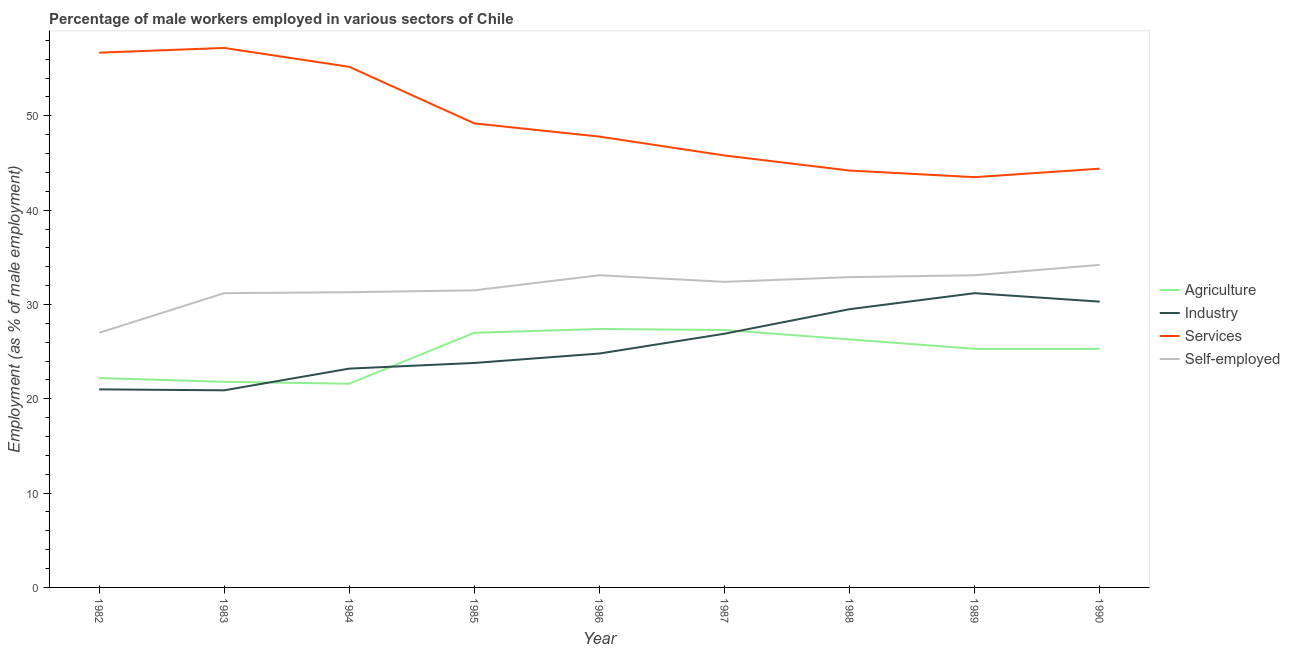Does the line corresponding to percentage of male workers in industry intersect with the line corresponding to percentage of male workers in agriculture?
Provide a short and direct response. Yes. Is the number of lines equal to the number of legend labels?
Your answer should be very brief. Yes. What is the percentage of male workers in services in 1982?
Keep it short and to the point. 56.7. Across all years, what is the maximum percentage of self employed male workers?
Your answer should be compact. 34.2. Across all years, what is the minimum percentage of male workers in services?
Give a very brief answer. 43.5. In which year was the percentage of self employed male workers maximum?
Your answer should be compact. 1990. What is the total percentage of self employed male workers in the graph?
Your answer should be very brief. 286.7. What is the difference between the percentage of male workers in agriculture in 1982 and that in 1987?
Provide a short and direct response. -5.1. What is the difference between the percentage of male workers in industry in 1982 and the percentage of male workers in services in 1987?
Give a very brief answer. -24.8. What is the average percentage of male workers in services per year?
Ensure brevity in your answer.  49.33. In the year 1985, what is the difference between the percentage of male workers in industry and percentage of male workers in services?
Ensure brevity in your answer.  -25.4. What is the ratio of the percentage of male workers in agriculture in 1989 to that in 1990?
Ensure brevity in your answer.  1. What is the difference between the highest and the second highest percentage of male workers in services?
Offer a very short reply. 0.5. What is the difference between the highest and the lowest percentage of male workers in services?
Your answer should be compact. 13.7. Is the sum of the percentage of male workers in industry in 1986 and 1988 greater than the maximum percentage of male workers in agriculture across all years?
Your answer should be compact. Yes. Is it the case that in every year, the sum of the percentage of male workers in industry and percentage of male workers in services is greater than the sum of percentage of self employed male workers and percentage of male workers in agriculture?
Make the answer very short. Yes. Does the percentage of male workers in agriculture monotonically increase over the years?
Offer a terse response. No. Is the percentage of male workers in services strictly less than the percentage of male workers in industry over the years?
Provide a succinct answer. No. How many lines are there?
Keep it short and to the point. 4. What is the difference between two consecutive major ticks on the Y-axis?
Ensure brevity in your answer.  10. Where does the legend appear in the graph?
Make the answer very short. Center right. What is the title of the graph?
Give a very brief answer. Percentage of male workers employed in various sectors of Chile. What is the label or title of the Y-axis?
Your answer should be compact. Employment (as % of male employment). What is the Employment (as % of male employment) in Agriculture in 1982?
Provide a short and direct response. 22.2. What is the Employment (as % of male employment) of Industry in 1982?
Offer a terse response. 21. What is the Employment (as % of male employment) of Services in 1982?
Keep it short and to the point. 56.7. What is the Employment (as % of male employment) of Self-employed in 1982?
Your response must be concise. 27. What is the Employment (as % of male employment) of Agriculture in 1983?
Provide a short and direct response. 21.8. What is the Employment (as % of male employment) of Industry in 1983?
Make the answer very short. 20.9. What is the Employment (as % of male employment) in Services in 1983?
Offer a terse response. 57.2. What is the Employment (as % of male employment) in Self-employed in 1983?
Provide a succinct answer. 31.2. What is the Employment (as % of male employment) in Agriculture in 1984?
Make the answer very short. 21.6. What is the Employment (as % of male employment) in Industry in 1984?
Your answer should be compact. 23.2. What is the Employment (as % of male employment) of Services in 1984?
Offer a very short reply. 55.2. What is the Employment (as % of male employment) of Self-employed in 1984?
Your answer should be compact. 31.3. What is the Employment (as % of male employment) of Industry in 1985?
Offer a terse response. 23.8. What is the Employment (as % of male employment) in Services in 1985?
Ensure brevity in your answer.  49.2. What is the Employment (as % of male employment) of Self-employed in 1985?
Make the answer very short. 31.5. What is the Employment (as % of male employment) in Agriculture in 1986?
Keep it short and to the point. 27.4. What is the Employment (as % of male employment) of Industry in 1986?
Your answer should be compact. 24.8. What is the Employment (as % of male employment) of Services in 1986?
Provide a short and direct response. 47.8. What is the Employment (as % of male employment) of Self-employed in 1986?
Give a very brief answer. 33.1. What is the Employment (as % of male employment) of Agriculture in 1987?
Provide a succinct answer. 27.3. What is the Employment (as % of male employment) in Industry in 1987?
Your answer should be very brief. 26.9. What is the Employment (as % of male employment) of Services in 1987?
Offer a terse response. 45.8. What is the Employment (as % of male employment) in Self-employed in 1987?
Make the answer very short. 32.4. What is the Employment (as % of male employment) in Agriculture in 1988?
Your answer should be compact. 26.3. What is the Employment (as % of male employment) of Industry in 1988?
Offer a very short reply. 29.5. What is the Employment (as % of male employment) in Services in 1988?
Provide a short and direct response. 44.2. What is the Employment (as % of male employment) of Self-employed in 1988?
Offer a very short reply. 32.9. What is the Employment (as % of male employment) of Agriculture in 1989?
Make the answer very short. 25.3. What is the Employment (as % of male employment) in Industry in 1989?
Offer a terse response. 31.2. What is the Employment (as % of male employment) of Services in 1989?
Provide a short and direct response. 43.5. What is the Employment (as % of male employment) of Self-employed in 1989?
Offer a very short reply. 33.1. What is the Employment (as % of male employment) in Agriculture in 1990?
Make the answer very short. 25.3. What is the Employment (as % of male employment) of Industry in 1990?
Your answer should be very brief. 30.3. What is the Employment (as % of male employment) of Services in 1990?
Provide a short and direct response. 44.4. What is the Employment (as % of male employment) in Self-employed in 1990?
Offer a very short reply. 34.2. Across all years, what is the maximum Employment (as % of male employment) of Agriculture?
Give a very brief answer. 27.4. Across all years, what is the maximum Employment (as % of male employment) in Industry?
Offer a very short reply. 31.2. Across all years, what is the maximum Employment (as % of male employment) in Services?
Offer a very short reply. 57.2. Across all years, what is the maximum Employment (as % of male employment) of Self-employed?
Your response must be concise. 34.2. Across all years, what is the minimum Employment (as % of male employment) of Agriculture?
Your answer should be compact. 21.6. Across all years, what is the minimum Employment (as % of male employment) in Industry?
Make the answer very short. 20.9. Across all years, what is the minimum Employment (as % of male employment) in Services?
Give a very brief answer. 43.5. What is the total Employment (as % of male employment) of Agriculture in the graph?
Provide a short and direct response. 224.2. What is the total Employment (as % of male employment) in Industry in the graph?
Keep it short and to the point. 231.6. What is the total Employment (as % of male employment) in Services in the graph?
Your answer should be compact. 444. What is the total Employment (as % of male employment) of Self-employed in the graph?
Make the answer very short. 286.7. What is the difference between the Employment (as % of male employment) in Agriculture in 1982 and that in 1983?
Make the answer very short. 0.4. What is the difference between the Employment (as % of male employment) of Industry in 1982 and that in 1983?
Offer a terse response. 0.1. What is the difference between the Employment (as % of male employment) of Self-employed in 1982 and that in 1983?
Your answer should be compact. -4.2. What is the difference between the Employment (as % of male employment) in Services in 1982 and that in 1984?
Give a very brief answer. 1.5. What is the difference between the Employment (as % of male employment) in Self-employed in 1982 and that in 1984?
Offer a very short reply. -4.3. What is the difference between the Employment (as % of male employment) in Agriculture in 1982 and that in 1985?
Offer a very short reply. -4.8. What is the difference between the Employment (as % of male employment) of Industry in 1982 and that in 1985?
Your answer should be compact. -2.8. What is the difference between the Employment (as % of male employment) of Self-employed in 1982 and that in 1985?
Provide a succinct answer. -4.5. What is the difference between the Employment (as % of male employment) of Agriculture in 1982 and that in 1986?
Your response must be concise. -5.2. What is the difference between the Employment (as % of male employment) of Agriculture in 1982 and that in 1987?
Ensure brevity in your answer.  -5.1. What is the difference between the Employment (as % of male employment) in Services in 1982 and that in 1987?
Give a very brief answer. 10.9. What is the difference between the Employment (as % of male employment) of Self-employed in 1982 and that in 1987?
Provide a short and direct response. -5.4. What is the difference between the Employment (as % of male employment) in Agriculture in 1982 and that in 1988?
Provide a short and direct response. -4.1. What is the difference between the Employment (as % of male employment) of Industry in 1982 and that in 1988?
Offer a very short reply. -8.5. What is the difference between the Employment (as % of male employment) in Services in 1982 and that in 1988?
Provide a succinct answer. 12.5. What is the difference between the Employment (as % of male employment) of Self-employed in 1982 and that in 1988?
Offer a terse response. -5.9. What is the difference between the Employment (as % of male employment) in Agriculture in 1982 and that in 1989?
Make the answer very short. -3.1. What is the difference between the Employment (as % of male employment) of Industry in 1982 and that in 1989?
Give a very brief answer. -10.2. What is the difference between the Employment (as % of male employment) of Services in 1982 and that in 1989?
Your answer should be very brief. 13.2. What is the difference between the Employment (as % of male employment) of Self-employed in 1982 and that in 1989?
Make the answer very short. -6.1. What is the difference between the Employment (as % of male employment) of Agriculture in 1982 and that in 1990?
Give a very brief answer. -3.1. What is the difference between the Employment (as % of male employment) in Agriculture in 1983 and that in 1984?
Keep it short and to the point. 0.2. What is the difference between the Employment (as % of male employment) of Self-employed in 1983 and that in 1984?
Provide a succinct answer. -0.1. What is the difference between the Employment (as % of male employment) of Industry in 1983 and that in 1985?
Give a very brief answer. -2.9. What is the difference between the Employment (as % of male employment) of Agriculture in 1983 and that in 1986?
Keep it short and to the point. -5.6. What is the difference between the Employment (as % of male employment) of Services in 1983 and that in 1986?
Offer a terse response. 9.4. What is the difference between the Employment (as % of male employment) of Self-employed in 1983 and that in 1986?
Your answer should be very brief. -1.9. What is the difference between the Employment (as % of male employment) in Agriculture in 1983 and that in 1987?
Give a very brief answer. -5.5. What is the difference between the Employment (as % of male employment) of Industry in 1983 and that in 1988?
Your answer should be compact. -8.6. What is the difference between the Employment (as % of male employment) of Services in 1983 and that in 1988?
Provide a succinct answer. 13. What is the difference between the Employment (as % of male employment) of Agriculture in 1983 and that in 1989?
Your answer should be compact. -3.5. What is the difference between the Employment (as % of male employment) of Industry in 1983 and that in 1989?
Provide a short and direct response. -10.3. What is the difference between the Employment (as % of male employment) of Agriculture in 1983 and that in 1990?
Offer a very short reply. -3.5. What is the difference between the Employment (as % of male employment) of Industry in 1983 and that in 1990?
Your response must be concise. -9.4. What is the difference between the Employment (as % of male employment) of Self-employed in 1983 and that in 1990?
Ensure brevity in your answer.  -3. What is the difference between the Employment (as % of male employment) in Industry in 1984 and that in 1985?
Provide a succinct answer. -0.6. What is the difference between the Employment (as % of male employment) of Self-employed in 1984 and that in 1985?
Your answer should be compact. -0.2. What is the difference between the Employment (as % of male employment) of Services in 1984 and that in 1986?
Keep it short and to the point. 7.4. What is the difference between the Employment (as % of male employment) in Services in 1984 and that in 1987?
Your answer should be very brief. 9.4. What is the difference between the Employment (as % of male employment) of Self-employed in 1984 and that in 1987?
Offer a terse response. -1.1. What is the difference between the Employment (as % of male employment) of Agriculture in 1984 and that in 1988?
Ensure brevity in your answer.  -4.7. What is the difference between the Employment (as % of male employment) in Industry in 1984 and that in 1988?
Your answer should be very brief. -6.3. What is the difference between the Employment (as % of male employment) of Self-employed in 1984 and that in 1988?
Your answer should be very brief. -1.6. What is the difference between the Employment (as % of male employment) in Agriculture in 1984 and that in 1989?
Keep it short and to the point. -3.7. What is the difference between the Employment (as % of male employment) in Industry in 1984 and that in 1989?
Offer a very short reply. -8. What is the difference between the Employment (as % of male employment) of Services in 1984 and that in 1989?
Give a very brief answer. 11.7. What is the difference between the Employment (as % of male employment) in Agriculture in 1984 and that in 1990?
Your answer should be very brief. -3.7. What is the difference between the Employment (as % of male employment) of Industry in 1984 and that in 1990?
Your answer should be compact. -7.1. What is the difference between the Employment (as % of male employment) of Services in 1984 and that in 1990?
Make the answer very short. 10.8. What is the difference between the Employment (as % of male employment) in Agriculture in 1985 and that in 1986?
Ensure brevity in your answer.  -0.4. What is the difference between the Employment (as % of male employment) in Industry in 1985 and that in 1986?
Your response must be concise. -1. What is the difference between the Employment (as % of male employment) of Services in 1985 and that in 1986?
Make the answer very short. 1.4. What is the difference between the Employment (as % of male employment) in Agriculture in 1985 and that in 1987?
Keep it short and to the point. -0.3. What is the difference between the Employment (as % of male employment) of Industry in 1985 and that in 1987?
Provide a short and direct response. -3.1. What is the difference between the Employment (as % of male employment) in Services in 1985 and that in 1987?
Your answer should be compact. 3.4. What is the difference between the Employment (as % of male employment) of Self-employed in 1985 and that in 1987?
Give a very brief answer. -0.9. What is the difference between the Employment (as % of male employment) in Industry in 1985 and that in 1988?
Ensure brevity in your answer.  -5.7. What is the difference between the Employment (as % of male employment) in Services in 1985 and that in 1988?
Keep it short and to the point. 5. What is the difference between the Employment (as % of male employment) of Industry in 1985 and that in 1989?
Give a very brief answer. -7.4. What is the difference between the Employment (as % of male employment) of Agriculture in 1985 and that in 1990?
Your response must be concise. 1.7. What is the difference between the Employment (as % of male employment) of Industry in 1985 and that in 1990?
Give a very brief answer. -6.5. What is the difference between the Employment (as % of male employment) in Services in 1985 and that in 1990?
Give a very brief answer. 4.8. What is the difference between the Employment (as % of male employment) of Agriculture in 1986 and that in 1987?
Provide a succinct answer. 0.1. What is the difference between the Employment (as % of male employment) in Industry in 1986 and that in 1987?
Provide a succinct answer. -2.1. What is the difference between the Employment (as % of male employment) of Services in 1986 and that in 1987?
Give a very brief answer. 2. What is the difference between the Employment (as % of male employment) in Self-employed in 1986 and that in 1987?
Offer a very short reply. 0.7. What is the difference between the Employment (as % of male employment) in Agriculture in 1986 and that in 1988?
Your answer should be very brief. 1.1. What is the difference between the Employment (as % of male employment) in Industry in 1986 and that in 1988?
Keep it short and to the point. -4.7. What is the difference between the Employment (as % of male employment) in Services in 1986 and that in 1988?
Provide a short and direct response. 3.6. What is the difference between the Employment (as % of male employment) in Industry in 1986 and that in 1989?
Provide a succinct answer. -6.4. What is the difference between the Employment (as % of male employment) in Services in 1986 and that in 1989?
Offer a very short reply. 4.3. What is the difference between the Employment (as % of male employment) in Industry in 1986 and that in 1990?
Your answer should be very brief. -5.5. What is the difference between the Employment (as % of male employment) in Self-employed in 1986 and that in 1990?
Offer a very short reply. -1.1. What is the difference between the Employment (as % of male employment) of Agriculture in 1987 and that in 1988?
Keep it short and to the point. 1. What is the difference between the Employment (as % of male employment) in Agriculture in 1987 and that in 1989?
Provide a short and direct response. 2. What is the difference between the Employment (as % of male employment) in Services in 1987 and that in 1989?
Offer a very short reply. 2.3. What is the difference between the Employment (as % of male employment) in Self-employed in 1987 and that in 1989?
Your response must be concise. -0.7. What is the difference between the Employment (as % of male employment) of Industry in 1987 and that in 1990?
Offer a very short reply. -3.4. What is the difference between the Employment (as % of male employment) of Services in 1987 and that in 1990?
Your answer should be compact. 1.4. What is the difference between the Employment (as % of male employment) in Services in 1988 and that in 1989?
Make the answer very short. 0.7. What is the difference between the Employment (as % of male employment) in Self-employed in 1988 and that in 1989?
Offer a terse response. -0.2. What is the difference between the Employment (as % of male employment) of Agriculture in 1988 and that in 1990?
Provide a succinct answer. 1. What is the difference between the Employment (as % of male employment) in Industry in 1989 and that in 1990?
Offer a terse response. 0.9. What is the difference between the Employment (as % of male employment) of Services in 1989 and that in 1990?
Ensure brevity in your answer.  -0.9. What is the difference between the Employment (as % of male employment) in Self-employed in 1989 and that in 1990?
Provide a succinct answer. -1.1. What is the difference between the Employment (as % of male employment) in Agriculture in 1982 and the Employment (as % of male employment) in Industry in 1983?
Your response must be concise. 1.3. What is the difference between the Employment (as % of male employment) in Agriculture in 1982 and the Employment (as % of male employment) in Services in 1983?
Provide a short and direct response. -35. What is the difference between the Employment (as % of male employment) in Industry in 1982 and the Employment (as % of male employment) in Services in 1983?
Provide a short and direct response. -36.2. What is the difference between the Employment (as % of male employment) of Services in 1982 and the Employment (as % of male employment) of Self-employed in 1983?
Offer a very short reply. 25.5. What is the difference between the Employment (as % of male employment) in Agriculture in 1982 and the Employment (as % of male employment) in Industry in 1984?
Give a very brief answer. -1. What is the difference between the Employment (as % of male employment) of Agriculture in 1982 and the Employment (as % of male employment) of Services in 1984?
Give a very brief answer. -33. What is the difference between the Employment (as % of male employment) of Industry in 1982 and the Employment (as % of male employment) of Services in 1984?
Ensure brevity in your answer.  -34.2. What is the difference between the Employment (as % of male employment) in Industry in 1982 and the Employment (as % of male employment) in Self-employed in 1984?
Your response must be concise. -10.3. What is the difference between the Employment (as % of male employment) of Services in 1982 and the Employment (as % of male employment) of Self-employed in 1984?
Keep it short and to the point. 25.4. What is the difference between the Employment (as % of male employment) in Agriculture in 1982 and the Employment (as % of male employment) in Services in 1985?
Offer a terse response. -27. What is the difference between the Employment (as % of male employment) of Agriculture in 1982 and the Employment (as % of male employment) of Self-employed in 1985?
Your answer should be very brief. -9.3. What is the difference between the Employment (as % of male employment) in Industry in 1982 and the Employment (as % of male employment) in Services in 1985?
Make the answer very short. -28.2. What is the difference between the Employment (as % of male employment) in Industry in 1982 and the Employment (as % of male employment) in Self-employed in 1985?
Your response must be concise. -10.5. What is the difference between the Employment (as % of male employment) of Services in 1982 and the Employment (as % of male employment) of Self-employed in 1985?
Ensure brevity in your answer.  25.2. What is the difference between the Employment (as % of male employment) of Agriculture in 1982 and the Employment (as % of male employment) of Industry in 1986?
Offer a terse response. -2.6. What is the difference between the Employment (as % of male employment) of Agriculture in 1982 and the Employment (as % of male employment) of Services in 1986?
Offer a terse response. -25.6. What is the difference between the Employment (as % of male employment) of Agriculture in 1982 and the Employment (as % of male employment) of Self-employed in 1986?
Keep it short and to the point. -10.9. What is the difference between the Employment (as % of male employment) in Industry in 1982 and the Employment (as % of male employment) in Services in 1986?
Keep it short and to the point. -26.8. What is the difference between the Employment (as % of male employment) in Industry in 1982 and the Employment (as % of male employment) in Self-employed in 1986?
Ensure brevity in your answer.  -12.1. What is the difference between the Employment (as % of male employment) in Services in 1982 and the Employment (as % of male employment) in Self-employed in 1986?
Offer a very short reply. 23.6. What is the difference between the Employment (as % of male employment) in Agriculture in 1982 and the Employment (as % of male employment) in Services in 1987?
Your answer should be compact. -23.6. What is the difference between the Employment (as % of male employment) in Agriculture in 1982 and the Employment (as % of male employment) in Self-employed in 1987?
Offer a very short reply. -10.2. What is the difference between the Employment (as % of male employment) in Industry in 1982 and the Employment (as % of male employment) in Services in 1987?
Your response must be concise. -24.8. What is the difference between the Employment (as % of male employment) in Industry in 1982 and the Employment (as % of male employment) in Self-employed in 1987?
Offer a very short reply. -11.4. What is the difference between the Employment (as % of male employment) in Services in 1982 and the Employment (as % of male employment) in Self-employed in 1987?
Offer a terse response. 24.3. What is the difference between the Employment (as % of male employment) of Agriculture in 1982 and the Employment (as % of male employment) of Industry in 1988?
Provide a short and direct response. -7.3. What is the difference between the Employment (as % of male employment) of Industry in 1982 and the Employment (as % of male employment) of Services in 1988?
Offer a very short reply. -23.2. What is the difference between the Employment (as % of male employment) in Services in 1982 and the Employment (as % of male employment) in Self-employed in 1988?
Your response must be concise. 23.8. What is the difference between the Employment (as % of male employment) in Agriculture in 1982 and the Employment (as % of male employment) in Services in 1989?
Your answer should be compact. -21.3. What is the difference between the Employment (as % of male employment) in Industry in 1982 and the Employment (as % of male employment) in Services in 1989?
Give a very brief answer. -22.5. What is the difference between the Employment (as % of male employment) of Services in 1982 and the Employment (as % of male employment) of Self-employed in 1989?
Your answer should be compact. 23.6. What is the difference between the Employment (as % of male employment) in Agriculture in 1982 and the Employment (as % of male employment) in Industry in 1990?
Your answer should be very brief. -8.1. What is the difference between the Employment (as % of male employment) in Agriculture in 1982 and the Employment (as % of male employment) in Services in 1990?
Provide a succinct answer. -22.2. What is the difference between the Employment (as % of male employment) in Industry in 1982 and the Employment (as % of male employment) in Services in 1990?
Offer a terse response. -23.4. What is the difference between the Employment (as % of male employment) in Services in 1982 and the Employment (as % of male employment) in Self-employed in 1990?
Your answer should be compact. 22.5. What is the difference between the Employment (as % of male employment) of Agriculture in 1983 and the Employment (as % of male employment) of Services in 1984?
Your answer should be compact. -33.4. What is the difference between the Employment (as % of male employment) in Industry in 1983 and the Employment (as % of male employment) in Services in 1984?
Your response must be concise. -34.3. What is the difference between the Employment (as % of male employment) of Industry in 1983 and the Employment (as % of male employment) of Self-employed in 1984?
Make the answer very short. -10.4. What is the difference between the Employment (as % of male employment) of Services in 1983 and the Employment (as % of male employment) of Self-employed in 1984?
Your answer should be compact. 25.9. What is the difference between the Employment (as % of male employment) of Agriculture in 1983 and the Employment (as % of male employment) of Industry in 1985?
Offer a very short reply. -2. What is the difference between the Employment (as % of male employment) of Agriculture in 1983 and the Employment (as % of male employment) of Services in 1985?
Offer a terse response. -27.4. What is the difference between the Employment (as % of male employment) of Industry in 1983 and the Employment (as % of male employment) of Services in 1985?
Keep it short and to the point. -28.3. What is the difference between the Employment (as % of male employment) in Industry in 1983 and the Employment (as % of male employment) in Self-employed in 1985?
Ensure brevity in your answer.  -10.6. What is the difference between the Employment (as % of male employment) of Services in 1983 and the Employment (as % of male employment) of Self-employed in 1985?
Ensure brevity in your answer.  25.7. What is the difference between the Employment (as % of male employment) in Agriculture in 1983 and the Employment (as % of male employment) in Self-employed in 1986?
Your answer should be very brief. -11.3. What is the difference between the Employment (as % of male employment) of Industry in 1983 and the Employment (as % of male employment) of Services in 1986?
Provide a short and direct response. -26.9. What is the difference between the Employment (as % of male employment) in Services in 1983 and the Employment (as % of male employment) in Self-employed in 1986?
Make the answer very short. 24.1. What is the difference between the Employment (as % of male employment) of Agriculture in 1983 and the Employment (as % of male employment) of Industry in 1987?
Keep it short and to the point. -5.1. What is the difference between the Employment (as % of male employment) in Agriculture in 1983 and the Employment (as % of male employment) in Self-employed in 1987?
Your response must be concise. -10.6. What is the difference between the Employment (as % of male employment) of Industry in 1983 and the Employment (as % of male employment) of Services in 1987?
Your response must be concise. -24.9. What is the difference between the Employment (as % of male employment) in Industry in 1983 and the Employment (as % of male employment) in Self-employed in 1987?
Offer a terse response. -11.5. What is the difference between the Employment (as % of male employment) of Services in 1983 and the Employment (as % of male employment) of Self-employed in 1987?
Your response must be concise. 24.8. What is the difference between the Employment (as % of male employment) of Agriculture in 1983 and the Employment (as % of male employment) of Services in 1988?
Offer a very short reply. -22.4. What is the difference between the Employment (as % of male employment) in Industry in 1983 and the Employment (as % of male employment) in Services in 1988?
Make the answer very short. -23.3. What is the difference between the Employment (as % of male employment) of Services in 1983 and the Employment (as % of male employment) of Self-employed in 1988?
Offer a very short reply. 24.3. What is the difference between the Employment (as % of male employment) in Agriculture in 1983 and the Employment (as % of male employment) in Industry in 1989?
Your answer should be compact. -9.4. What is the difference between the Employment (as % of male employment) of Agriculture in 1983 and the Employment (as % of male employment) of Services in 1989?
Your answer should be compact. -21.7. What is the difference between the Employment (as % of male employment) of Agriculture in 1983 and the Employment (as % of male employment) of Self-employed in 1989?
Provide a succinct answer. -11.3. What is the difference between the Employment (as % of male employment) of Industry in 1983 and the Employment (as % of male employment) of Services in 1989?
Your response must be concise. -22.6. What is the difference between the Employment (as % of male employment) in Industry in 1983 and the Employment (as % of male employment) in Self-employed in 1989?
Your answer should be compact. -12.2. What is the difference between the Employment (as % of male employment) in Services in 1983 and the Employment (as % of male employment) in Self-employed in 1989?
Ensure brevity in your answer.  24.1. What is the difference between the Employment (as % of male employment) of Agriculture in 1983 and the Employment (as % of male employment) of Services in 1990?
Your answer should be compact. -22.6. What is the difference between the Employment (as % of male employment) in Industry in 1983 and the Employment (as % of male employment) in Services in 1990?
Provide a succinct answer. -23.5. What is the difference between the Employment (as % of male employment) of Services in 1983 and the Employment (as % of male employment) of Self-employed in 1990?
Offer a very short reply. 23. What is the difference between the Employment (as % of male employment) in Agriculture in 1984 and the Employment (as % of male employment) in Services in 1985?
Your answer should be compact. -27.6. What is the difference between the Employment (as % of male employment) of Services in 1984 and the Employment (as % of male employment) of Self-employed in 1985?
Your answer should be compact. 23.7. What is the difference between the Employment (as % of male employment) of Agriculture in 1984 and the Employment (as % of male employment) of Services in 1986?
Your answer should be very brief. -26.2. What is the difference between the Employment (as % of male employment) in Agriculture in 1984 and the Employment (as % of male employment) in Self-employed in 1986?
Provide a short and direct response. -11.5. What is the difference between the Employment (as % of male employment) of Industry in 1984 and the Employment (as % of male employment) of Services in 1986?
Your answer should be compact. -24.6. What is the difference between the Employment (as % of male employment) of Industry in 1984 and the Employment (as % of male employment) of Self-employed in 1986?
Give a very brief answer. -9.9. What is the difference between the Employment (as % of male employment) of Services in 1984 and the Employment (as % of male employment) of Self-employed in 1986?
Ensure brevity in your answer.  22.1. What is the difference between the Employment (as % of male employment) of Agriculture in 1984 and the Employment (as % of male employment) of Services in 1987?
Offer a terse response. -24.2. What is the difference between the Employment (as % of male employment) in Agriculture in 1984 and the Employment (as % of male employment) in Self-employed in 1987?
Give a very brief answer. -10.8. What is the difference between the Employment (as % of male employment) in Industry in 1984 and the Employment (as % of male employment) in Services in 1987?
Ensure brevity in your answer.  -22.6. What is the difference between the Employment (as % of male employment) of Services in 1984 and the Employment (as % of male employment) of Self-employed in 1987?
Provide a succinct answer. 22.8. What is the difference between the Employment (as % of male employment) of Agriculture in 1984 and the Employment (as % of male employment) of Industry in 1988?
Offer a terse response. -7.9. What is the difference between the Employment (as % of male employment) of Agriculture in 1984 and the Employment (as % of male employment) of Services in 1988?
Offer a very short reply. -22.6. What is the difference between the Employment (as % of male employment) in Industry in 1984 and the Employment (as % of male employment) in Services in 1988?
Offer a terse response. -21. What is the difference between the Employment (as % of male employment) of Industry in 1984 and the Employment (as % of male employment) of Self-employed in 1988?
Your answer should be compact. -9.7. What is the difference between the Employment (as % of male employment) of Services in 1984 and the Employment (as % of male employment) of Self-employed in 1988?
Offer a very short reply. 22.3. What is the difference between the Employment (as % of male employment) of Agriculture in 1984 and the Employment (as % of male employment) of Services in 1989?
Offer a very short reply. -21.9. What is the difference between the Employment (as % of male employment) of Agriculture in 1984 and the Employment (as % of male employment) of Self-employed in 1989?
Your answer should be compact. -11.5. What is the difference between the Employment (as % of male employment) of Industry in 1984 and the Employment (as % of male employment) of Services in 1989?
Give a very brief answer. -20.3. What is the difference between the Employment (as % of male employment) of Industry in 1984 and the Employment (as % of male employment) of Self-employed in 1989?
Your response must be concise. -9.9. What is the difference between the Employment (as % of male employment) in Services in 1984 and the Employment (as % of male employment) in Self-employed in 1989?
Offer a terse response. 22.1. What is the difference between the Employment (as % of male employment) in Agriculture in 1984 and the Employment (as % of male employment) in Industry in 1990?
Give a very brief answer. -8.7. What is the difference between the Employment (as % of male employment) of Agriculture in 1984 and the Employment (as % of male employment) of Services in 1990?
Provide a short and direct response. -22.8. What is the difference between the Employment (as % of male employment) of Agriculture in 1984 and the Employment (as % of male employment) of Self-employed in 1990?
Offer a very short reply. -12.6. What is the difference between the Employment (as % of male employment) in Industry in 1984 and the Employment (as % of male employment) in Services in 1990?
Offer a very short reply. -21.2. What is the difference between the Employment (as % of male employment) in Industry in 1984 and the Employment (as % of male employment) in Self-employed in 1990?
Offer a very short reply. -11. What is the difference between the Employment (as % of male employment) of Agriculture in 1985 and the Employment (as % of male employment) of Services in 1986?
Offer a very short reply. -20.8. What is the difference between the Employment (as % of male employment) of Agriculture in 1985 and the Employment (as % of male employment) of Self-employed in 1986?
Offer a terse response. -6.1. What is the difference between the Employment (as % of male employment) in Services in 1985 and the Employment (as % of male employment) in Self-employed in 1986?
Keep it short and to the point. 16.1. What is the difference between the Employment (as % of male employment) in Agriculture in 1985 and the Employment (as % of male employment) in Services in 1987?
Your answer should be compact. -18.8. What is the difference between the Employment (as % of male employment) in Agriculture in 1985 and the Employment (as % of male employment) in Self-employed in 1987?
Provide a succinct answer. -5.4. What is the difference between the Employment (as % of male employment) in Industry in 1985 and the Employment (as % of male employment) in Services in 1987?
Give a very brief answer. -22. What is the difference between the Employment (as % of male employment) in Industry in 1985 and the Employment (as % of male employment) in Self-employed in 1987?
Give a very brief answer. -8.6. What is the difference between the Employment (as % of male employment) of Agriculture in 1985 and the Employment (as % of male employment) of Services in 1988?
Offer a very short reply. -17.2. What is the difference between the Employment (as % of male employment) in Agriculture in 1985 and the Employment (as % of male employment) in Self-employed in 1988?
Give a very brief answer. -5.9. What is the difference between the Employment (as % of male employment) of Industry in 1985 and the Employment (as % of male employment) of Services in 1988?
Keep it short and to the point. -20.4. What is the difference between the Employment (as % of male employment) of Industry in 1985 and the Employment (as % of male employment) of Self-employed in 1988?
Give a very brief answer. -9.1. What is the difference between the Employment (as % of male employment) in Agriculture in 1985 and the Employment (as % of male employment) in Services in 1989?
Offer a terse response. -16.5. What is the difference between the Employment (as % of male employment) in Agriculture in 1985 and the Employment (as % of male employment) in Self-employed in 1989?
Your answer should be compact. -6.1. What is the difference between the Employment (as % of male employment) in Industry in 1985 and the Employment (as % of male employment) in Services in 1989?
Your answer should be compact. -19.7. What is the difference between the Employment (as % of male employment) of Services in 1985 and the Employment (as % of male employment) of Self-employed in 1989?
Ensure brevity in your answer.  16.1. What is the difference between the Employment (as % of male employment) in Agriculture in 1985 and the Employment (as % of male employment) in Services in 1990?
Offer a terse response. -17.4. What is the difference between the Employment (as % of male employment) of Industry in 1985 and the Employment (as % of male employment) of Services in 1990?
Make the answer very short. -20.6. What is the difference between the Employment (as % of male employment) of Industry in 1985 and the Employment (as % of male employment) of Self-employed in 1990?
Make the answer very short. -10.4. What is the difference between the Employment (as % of male employment) of Agriculture in 1986 and the Employment (as % of male employment) of Industry in 1987?
Give a very brief answer. 0.5. What is the difference between the Employment (as % of male employment) of Agriculture in 1986 and the Employment (as % of male employment) of Services in 1987?
Offer a very short reply. -18.4. What is the difference between the Employment (as % of male employment) in Industry in 1986 and the Employment (as % of male employment) in Services in 1987?
Make the answer very short. -21. What is the difference between the Employment (as % of male employment) in Industry in 1986 and the Employment (as % of male employment) in Self-employed in 1987?
Provide a succinct answer. -7.6. What is the difference between the Employment (as % of male employment) in Services in 1986 and the Employment (as % of male employment) in Self-employed in 1987?
Make the answer very short. 15.4. What is the difference between the Employment (as % of male employment) of Agriculture in 1986 and the Employment (as % of male employment) of Services in 1988?
Ensure brevity in your answer.  -16.8. What is the difference between the Employment (as % of male employment) of Industry in 1986 and the Employment (as % of male employment) of Services in 1988?
Provide a short and direct response. -19.4. What is the difference between the Employment (as % of male employment) of Industry in 1986 and the Employment (as % of male employment) of Self-employed in 1988?
Your response must be concise. -8.1. What is the difference between the Employment (as % of male employment) in Services in 1986 and the Employment (as % of male employment) in Self-employed in 1988?
Your response must be concise. 14.9. What is the difference between the Employment (as % of male employment) in Agriculture in 1986 and the Employment (as % of male employment) in Industry in 1989?
Offer a terse response. -3.8. What is the difference between the Employment (as % of male employment) in Agriculture in 1986 and the Employment (as % of male employment) in Services in 1989?
Your response must be concise. -16.1. What is the difference between the Employment (as % of male employment) in Industry in 1986 and the Employment (as % of male employment) in Services in 1989?
Make the answer very short. -18.7. What is the difference between the Employment (as % of male employment) in Services in 1986 and the Employment (as % of male employment) in Self-employed in 1989?
Keep it short and to the point. 14.7. What is the difference between the Employment (as % of male employment) in Agriculture in 1986 and the Employment (as % of male employment) in Industry in 1990?
Keep it short and to the point. -2.9. What is the difference between the Employment (as % of male employment) of Agriculture in 1986 and the Employment (as % of male employment) of Self-employed in 1990?
Provide a short and direct response. -6.8. What is the difference between the Employment (as % of male employment) of Industry in 1986 and the Employment (as % of male employment) of Services in 1990?
Give a very brief answer. -19.6. What is the difference between the Employment (as % of male employment) of Agriculture in 1987 and the Employment (as % of male employment) of Industry in 1988?
Provide a succinct answer. -2.2. What is the difference between the Employment (as % of male employment) of Agriculture in 1987 and the Employment (as % of male employment) of Services in 1988?
Make the answer very short. -16.9. What is the difference between the Employment (as % of male employment) in Agriculture in 1987 and the Employment (as % of male employment) in Self-employed in 1988?
Your answer should be very brief. -5.6. What is the difference between the Employment (as % of male employment) in Industry in 1987 and the Employment (as % of male employment) in Services in 1988?
Ensure brevity in your answer.  -17.3. What is the difference between the Employment (as % of male employment) of Industry in 1987 and the Employment (as % of male employment) of Self-employed in 1988?
Offer a very short reply. -6. What is the difference between the Employment (as % of male employment) in Services in 1987 and the Employment (as % of male employment) in Self-employed in 1988?
Ensure brevity in your answer.  12.9. What is the difference between the Employment (as % of male employment) of Agriculture in 1987 and the Employment (as % of male employment) of Industry in 1989?
Make the answer very short. -3.9. What is the difference between the Employment (as % of male employment) of Agriculture in 1987 and the Employment (as % of male employment) of Services in 1989?
Ensure brevity in your answer.  -16.2. What is the difference between the Employment (as % of male employment) in Agriculture in 1987 and the Employment (as % of male employment) in Self-employed in 1989?
Your answer should be very brief. -5.8. What is the difference between the Employment (as % of male employment) of Industry in 1987 and the Employment (as % of male employment) of Services in 1989?
Offer a very short reply. -16.6. What is the difference between the Employment (as % of male employment) of Agriculture in 1987 and the Employment (as % of male employment) of Industry in 1990?
Make the answer very short. -3. What is the difference between the Employment (as % of male employment) of Agriculture in 1987 and the Employment (as % of male employment) of Services in 1990?
Your response must be concise. -17.1. What is the difference between the Employment (as % of male employment) of Agriculture in 1987 and the Employment (as % of male employment) of Self-employed in 1990?
Offer a terse response. -6.9. What is the difference between the Employment (as % of male employment) in Industry in 1987 and the Employment (as % of male employment) in Services in 1990?
Make the answer very short. -17.5. What is the difference between the Employment (as % of male employment) of Industry in 1987 and the Employment (as % of male employment) of Self-employed in 1990?
Provide a short and direct response. -7.3. What is the difference between the Employment (as % of male employment) in Agriculture in 1988 and the Employment (as % of male employment) in Services in 1989?
Provide a succinct answer. -17.2. What is the difference between the Employment (as % of male employment) in Industry in 1988 and the Employment (as % of male employment) in Services in 1989?
Give a very brief answer. -14. What is the difference between the Employment (as % of male employment) in Services in 1988 and the Employment (as % of male employment) in Self-employed in 1989?
Make the answer very short. 11.1. What is the difference between the Employment (as % of male employment) in Agriculture in 1988 and the Employment (as % of male employment) in Industry in 1990?
Provide a short and direct response. -4. What is the difference between the Employment (as % of male employment) in Agriculture in 1988 and the Employment (as % of male employment) in Services in 1990?
Provide a succinct answer. -18.1. What is the difference between the Employment (as % of male employment) of Agriculture in 1988 and the Employment (as % of male employment) of Self-employed in 1990?
Ensure brevity in your answer.  -7.9. What is the difference between the Employment (as % of male employment) of Industry in 1988 and the Employment (as % of male employment) of Services in 1990?
Offer a very short reply. -14.9. What is the difference between the Employment (as % of male employment) in Industry in 1988 and the Employment (as % of male employment) in Self-employed in 1990?
Give a very brief answer. -4.7. What is the difference between the Employment (as % of male employment) in Agriculture in 1989 and the Employment (as % of male employment) in Industry in 1990?
Provide a succinct answer. -5. What is the difference between the Employment (as % of male employment) in Agriculture in 1989 and the Employment (as % of male employment) in Services in 1990?
Your response must be concise. -19.1. What is the difference between the Employment (as % of male employment) in Agriculture in 1989 and the Employment (as % of male employment) in Self-employed in 1990?
Your answer should be very brief. -8.9. What is the difference between the Employment (as % of male employment) of Industry in 1989 and the Employment (as % of male employment) of Services in 1990?
Your answer should be very brief. -13.2. What is the average Employment (as % of male employment) of Agriculture per year?
Your answer should be compact. 24.91. What is the average Employment (as % of male employment) of Industry per year?
Offer a terse response. 25.73. What is the average Employment (as % of male employment) in Services per year?
Provide a succinct answer. 49.33. What is the average Employment (as % of male employment) in Self-employed per year?
Your response must be concise. 31.86. In the year 1982, what is the difference between the Employment (as % of male employment) in Agriculture and Employment (as % of male employment) in Industry?
Offer a terse response. 1.2. In the year 1982, what is the difference between the Employment (as % of male employment) in Agriculture and Employment (as % of male employment) in Services?
Your answer should be very brief. -34.5. In the year 1982, what is the difference between the Employment (as % of male employment) of Agriculture and Employment (as % of male employment) of Self-employed?
Provide a succinct answer. -4.8. In the year 1982, what is the difference between the Employment (as % of male employment) of Industry and Employment (as % of male employment) of Services?
Your answer should be compact. -35.7. In the year 1982, what is the difference between the Employment (as % of male employment) of Services and Employment (as % of male employment) of Self-employed?
Give a very brief answer. 29.7. In the year 1983, what is the difference between the Employment (as % of male employment) of Agriculture and Employment (as % of male employment) of Industry?
Offer a terse response. 0.9. In the year 1983, what is the difference between the Employment (as % of male employment) in Agriculture and Employment (as % of male employment) in Services?
Your answer should be very brief. -35.4. In the year 1983, what is the difference between the Employment (as % of male employment) in Agriculture and Employment (as % of male employment) in Self-employed?
Keep it short and to the point. -9.4. In the year 1983, what is the difference between the Employment (as % of male employment) in Industry and Employment (as % of male employment) in Services?
Offer a terse response. -36.3. In the year 1983, what is the difference between the Employment (as % of male employment) of Services and Employment (as % of male employment) of Self-employed?
Offer a very short reply. 26. In the year 1984, what is the difference between the Employment (as % of male employment) of Agriculture and Employment (as % of male employment) of Services?
Ensure brevity in your answer.  -33.6. In the year 1984, what is the difference between the Employment (as % of male employment) in Agriculture and Employment (as % of male employment) in Self-employed?
Your answer should be very brief. -9.7. In the year 1984, what is the difference between the Employment (as % of male employment) of Industry and Employment (as % of male employment) of Services?
Offer a terse response. -32. In the year 1984, what is the difference between the Employment (as % of male employment) of Industry and Employment (as % of male employment) of Self-employed?
Make the answer very short. -8.1. In the year 1984, what is the difference between the Employment (as % of male employment) of Services and Employment (as % of male employment) of Self-employed?
Offer a very short reply. 23.9. In the year 1985, what is the difference between the Employment (as % of male employment) in Agriculture and Employment (as % of male employment) in Services?
Offer a terse response. -22.2. In the year 1985, what is the difference between the Employment (as % of male employment) of Agriculture and Employment (as % of male employment) of Self-employed?
Your answer should be compact. -4.5. In the year 1985, what is the difference between the Employment (as % of male employment) of Industry and Employment (as % of male employment) of Services?
Offer a very short reply. -25.4. In the year 1986, what is the difference between the Employment (as % of male employment) of Agriculture and Employment (as % of male employment) of Services?
Make the answer very short. -20.4. In the year 1986, what is the difference between the Employment (as % of male employment) of Agriculture and Employment (as % of male employment) of Self-employed?
Keep it short and to the point. -5.7. In the year 1986, what is the difference between the Employment (as % of male employment) of Industry and Employment (as % of male employment) of Services?
Offer a very short reply. -23. In the year 1987, what is the difference between the Employment (as % of male employment) of Agriculture and Employment (as % of male employment) of Industry?
Make the answer very short. 0.4. In the year 1987, what is the difference between the Employment (as % of male employment) in Agriculture and Employment (as % of male employment) in Services?
Provide a succinct answer. -18.5. In the year 1987, what is the difference between the Employment (as % of male employment) in Agriculture and Employment (as % of male employment) in Self-employed?
Your answer should be very brief. -5.1. In the year 1987, what is the difference between the Employment (as % of male employment) in Industry and Employment (as % of male employment) in Services?
Keep it short and to the point. -18.9. In the year 1987, what is the difference between the Employment (as % of male employment) in Services and Employment (as % of male employment) in Self-employed?
Give a very brief answer. 13.4. In the year 1988, what is the difference between the Employment (as % of male employment) in Agriculture and Employment (as % of male employment) in Services?
Make the answer very short. -17.9. In the year 1988, what is the difference between the Employment (as % of male employment) of Industry and Employment (as % of male employment) of Services?
Offer a very short reply. -14.7. In the year 1988, what is the difference between the Employment (as % of male employment) in Industry and Employment (as % of male employment) in Self-employed?
Your response must be concise. -3.4. In the year 1988, what is the difference between the Employment (as % of male employment) of Services and Employment (as % of male employment) of Self-employed?
Offer a terse response. 11.3. In the year 1989, what is the difference between the Employment (as % of male employment) of Agriculture and Employment (as % of male employment) of Services?
Offer a terse response. -18.2. In the year 1989, what is the difference between the Employment (as % of male employment) in Industry and Employment (as % of male employment) in Services?
Give a very brief answer. -12.3. In the year 1989, what is the difference between the Employment (as % of male employment) of Industry and Employment (as % of male employment) of Self-employed?
Keep it short and to the point. -1.9. In the year 1989, what is the difference between the Employment (as % of male employment) in Services and Employment (as % of male employment) in Self-employed?
Offer a terse response. 10.4. In the year 1990, what is the difference between the Employment (as % of male employment) in Agriculture and Employment (as % of male employment) in Services?
Keep it short and to the point. -19.1. In the year 1990, what is the difference between the Employment (as % of male employment) of Industry and Employment (as % of male employment) of Services?
Your answer should be very brief. -14.1. In the year 1990, what is the difference between the Employment (as % of male employment) in Industry and Employment (as % of male employment) in Self-employed?
Your response must be concise. -3.9. What is the ratio of the Employment (as % of male employment) in Agriculture in 1982 to that in 1983?
Ensure brevity in your answer.  1.02. What is the ratio of the Employment (as % of male employment) of Industry in 1982 to that in 1983?
Provide a short and direct response. 1. What is the ratio of the Employment (as % of male employment) of Services in 1982 to that in 1983?
Your answer should be compact. 0.99. What is the ratio of the Employment (as % of male employment) in Self-employed in 1982 to that in 1983?
Your answer should be very brief. 0.87. What is the ratio of the Employment (as % of male employment) in Agriculture in 1982 to that in 1984?
Give a very brief answer. 1.03. What is the ratio of the Employment (as % of male employment) in Industry in 1982 to that in 1984?
Your response must be concise. 0.91. What is the ratio of the Employment (as % of male employment) of Services in 1982 to that in 1984?
Offer a terse response. 1.03. What is the ratio of the Employment (as % of male employment) in Self-employed in 1982 to that in 1984?
Ensure brevity in your answer.  0.86. What is the ratio of the Employment (as % of male employment) in Agriculture in 1982 to that in 1985?
Your answer should be compact. 0.82. What is the ratio of the Employment (as % of male employment) of Industry in 1982 to that in 1985?
Your answer should be compact. 0.88. What is the ratio of the Employment (as % of male employment) of Services in 1982 to that in 1985?
Give a very brief answer. 1.15. What is the ratio of the Employment (as % of male employment) in Self-employed in 1982 to that in 1985?
Keep it short and to the point. 0.86. What is the ratio of the Employment (as % of male employment) in Agriculture in 1982 to that in 1986?
Your answer should be compact. 0.81. What is the ratio of the Employment (as % of male employment) in Industry in 1982 to that in 1986?
Your answer should be very brief. 0.85. What is the ratio of the Employment (as % of male employment) of Services in 1982 to that in 1986?
Your answer should be compact. 1.19. What is the ratio of the Employment (as % of male employment) in Self-employed in 1982 to that in 1986?
Your response must be concise. 0.82. What is the ratio of the Employment (as % of male employment) in Agriculture in 1982 to that in 1987?
Provide a succinct answer. 0.81. What is the ratio of the Employment (as % of male employment) of Industry in 1982 to that in 1987?
Give a very brief answer. 0.78. What is the ratio of the Employment (as % of male employment) of Services in 1982 to that in 1987?
Provide a succinct answer. 1.24. What is the ratio of the Employment (as % of male employment) of Agriculture in 1982 to that in 1988?
Offer a very short reply. 0.84. What is the ratio of the Employment (as % of male employment) of Industry in 1982 to that in 1988?
Provide a short and direct response. 0.71. What is the ratio of the Employment (as % of male employment) of Services in 1982 to that in 1988?
Your response must be concise. 1.28. What is the ratio of the Employment (as % of male employment) in Self-employed in 1982 to that in 1988?
Your answer should be compact. 0.82. What is the ratio of the Employment (as % of male employment) in Agriculture in 1982 to that in 1989?
Provide a succinct answer. 0.88. What is the ratio of the Employment (as % of male employment) of Industry in 1982 to that in 1989?
Provide a succinct answer. 0.67. What is the ratio of the Employment (as % of male employment) of Services in 1982 to that in 1989?
Your answer should be very brief. 1.3. What is the ratio of the Employment (as % of male employment) in Self-employed in 1982 to that in 1989?
Ensure brevity in your answer.  0.82. What is the ratio of the Employment (as % of male employment) in Agriculture in 1982 to that in 1990?
Keep it short and to the point. 0.88. What is the ratio of the Employment (as % of male employment) in Industry in 1982 to that in 1990?
Provide a succinct answer. 0.69. What is the ratio of the Employment (as % of male employment) of Services in 1982 to that in 1990?
Give a very brief answer. 1.28. What is the ratio of the Employment (as % of male employment) in Self-employed in 1982 to that in 1990?
Ensure brevity in your answer.  0.79. What is the ratio of the Employment (as % of male employment) in Agriculture in 1983 to that in 1984?
Ensure brevity in your answer.  1.01. What is the ratio of the Employment (as % of male employment) in Industry in 1983 to that in 1984?
Ensure brevity in your answer.  0.9. What is the ratio of the Employment (as % of male employment) of Services in 1983 to that in 1984?
Provide a short and direct response. 1.04. What is the ratio of the Employment (as % of male employment) in Agriculture in 1983 to that in 1985?
Give a very brief answer. 0.81. What is the ratio of the Employment (as % of male employment) in Industry in 1983 to that in 1985?
Offer a terse response. 0.88. What is the ratio of the Employment (as % of male employment) of Services in 1983 to that in 1985?
Your response must be concise. 1.16. What is the ratio of the Employment (as % of male employment) of Self-employed in 1983 to that in 1985?
Your answer should be very brief. 0.99. What is the ratio of the Employment (as % of male employment) of Agriculture in 1983 to that in 1986?
Ensure brevity in your answer.  0.8. What is the ratio of the Employment (as % of male employment) of Industry in 1983 to that in 1986?
Your answer should be very brief. 0.84. What is the ratio of the Employment (as % of male employment) in Services in 1983 to that in 1986?
Keep it short and to the point. 1.2. What is the ratio of the Employment (as % of male employment) in Self-employed in 1983 to that in 1986?
Give a very brief answer. 0.94. What is the ratio of the Employment (as % of male employment) in Agriculture in 1983 to that in 1987?
Give a very brief answer. 0.8. What is the ratio of the Employment (as % of male employment) of Industry in 1983 to that in 1987?
Offer a terse response. 0.78. What is the ratio of the Employment (as % of male employment) in Services in 1983 to that in 1987?
Ensure brevity in your answer.  1.25. What is the ratio of the Employment (as % of male employment) in Self-employed in 1983 to that in 1987?
Offer a very short reply. 0.96. What is the ratio of the Employment (as % of male employment) in Agriculture in 1983 to that in 1988?
Make the answer very short. 0.83. What is the ratio of the Employment (as % of male employment) of Industry in 1983 to that in 1988?
Your answer should be very brief. 0.71. What is the ratio of the Employment (as % of male employment) of Services in 1983 to that in 1988?
Give a very brief answer. 1.29. What is the ratio of the Employment (as % of male employment) of Self-employed in 1983 to that in 1988?
Offer a terse response. 0.95. What is the ratio of the Employment (as % of male employment) of Agriculture in 1983 to that in 1989?
Keep it short and to the point. 0.86. What is the ratio of the Employment (as % of male employment) in Industry in 1983 to that in 1989?
Give a very brief answer. 0.67. What is the ratio of the Employment (as % of male employment) of Services in 1983 to that in 1989?
Give a very brief answer. 1.31. What is the ratio of the Employment (as % of male employment) of Self-employed in 1983 to that in 1989?
Offer a very short reply. 0.94. What is the ratio of the Employment (as % of male employment) of Agriculture in 1983 to that in 1990?
Ensure brevity in your answer.  0.86. What is the ratio of the Employment (as % of male employment) of Industry in 1983 to that in 1990?
Your response must be concise. 0.69. What is the ratio of the Employment (as % of male employment) of Services in 1983 to that in 1990?
Your answer should be compact. 1.29. What is the ratio of the Employment (as % of male employment) of Self-employed in 1983 to that in 1990?
Your answer should be very brief. 0.91. What is the ratio of the Employment (as % of male employment) in Agriculture in 1984 to that in 1985?
Ensure brevity in your answer.  0.8. What is the ratio of the Employment (as % of male employment) of Industry in 1984 to that in 1985?
Keep it short and to the point. 0.97. What is the ratio of the Employment (as % of male employment) in Services in 1984 to that in 1985?
Give a very brief answer. 1.12. What is the ratio of the Employment (as % of male employment) of Self-employed in 1984 to that in 1985?
Give a very brief answer. 0.99. What is the ratio of the Employment (as % of male employment) in Agriculture in 1984 to that in 1986?
Provide a succinct answer. 0.79. What is the ratio of the Employment (as % of male employment) in Industry in 1984 to that in 1986?
Offer a terse response. 0.94. What is the ratio of the Employment (as % of male employment) of Services in 1984 to that in 1986?
Provide a succinct answer. 1.15. What is the ratio of the Employment (as % of male employment) of Self-employed in 1984 to that in 1986?
Offer a terse response. 0.95. What is the ratio of the Employment (as % of male employment) in Agriculture in 1984 to that in 1987?
Offer a terse response. 0.79. What is the ratio of the Employment (as % of male employment) of Industry in 1984 to that in 1987?
Your answer should be very brief. 0.86. What is the ratio of the Employment (as % of male employment) in Services in 1984 to that in 1987?
Make the answer very short. 1.21. What is the ratio of the Employment (as % of male employment) of Agriculture in 1984 to that in 1988?
Give a very brief answer. 0.82. What is the ratio of the Employment (as % of male employment) of Industry in 1984 to that in 1988?
Your answer should be compact. 0.79. What is the ratio of the Employment (as % of male employment) of Services in 1984 to that in 1988?
Keep it short and to the point. 1.25. What is the ratio of the Employment (as % of male employment) of Self-employed in 1984 to that in 1988?
Make the answer very short. 0.95. What is the ratio of the Employment (as % of male employment) in Agriculture in 1984 to that in 1989?
Provide a succinct answer. 0.85. What is the ratio of the Employment (as % of male employment) in Industry in 1984 to that in 1989?
Your answer should be compact. 0.74. What is the ratio of the Employment (as % of male employment) of Services in 1984 to that in 1989?
Give a very brief answer. 1.27. What is the ratio of the Employment (as % of male employment) of Self-employed in 1984 to that in 1989?
Offer a very short reply. 0.95. What is the ratio of the Employment (as % of male employment) of Agriculture in 1984 to that in 1990?
Your answer should be compact. 0.85. What is the ratio of the Employment (as % of male employment) in Industry in 1984 to that in 1990?
Give a very brief answer. 0.77. What is the ratio of the Employment (as % of male employment) in Services in 1984 to that in 1990?
Your response must be concise. 1.24. What is the ratio of the Employment (as % of male employment) of Self-employed in 1984 to that in 1990?
Provide a short and direct response. 0.92. What is the ratio of the Employment (as % of male employment) of Agriculture in 1985 to that in 1986?
Ensure brevity in your answer.  0.99. What is the ratio of the Employment (as % of male employment) in Industry in 1985 to that in 1986?
Make the answer very short. 0.96. What is the ratio of the Employment (as % of male employment) of Services in 1985 to that in 1986?
Your answer should be very brief. 1.03. What is the ratio of the Employment (as % of male employment) in Self-employed in 1985 to that in 1986?
Your answer should be compact. 0.95. What is the ratio of the Employment (as % of male employment) of Agriculture in 1985 to that in 1987?
Offer a very short reply. 0.99. What is the ratio of the Employment (as % of male employment) of Industry in 1985 to that in 1987?
Give a very brief answer. 0.88. What is the ratio of the Employment (as % of male employment) of Services in 1985 to that in 1987?
Provide a short and direct response. 1.07. What is the ratio of the Employment (as % of male employment) of Self-employed in 1985 to that in 1987?
Keep it short and to the point. 0.97. What is the ratio of the Employment (as % of male employment) in Agriculture in 1985 to that in 1988?
Provide a short and direct response. 1.03. What is the ratio of the Employment (as % of male employment) in Industry in 1985 to that in 1988?
Offer a very short reply. 0.81. What is the ratio of the Employment (as % of male employment) in Services in 1985 to that in 1988?
Your response must be concise. 1.11. What is the ratio of the Employment (as % of male employment) of Self-employed in 1985 to that in 1988?
Offer a terse response. 0.96. What is the ratio of the Employment (as % of male employment) of Agriculture in 1985 to that in 1989?
Your response must be concise. 1.07. What is the ratio of the Employment (as % of male employment) of Industry in 1985 to that in 1989?
Your answer should be compact. 0.76. What is the ratio of the Employment (as % of male employment) in Services in 1985 to that in 1989?
Your response must be concise. 1.13. What is the ratio of the Employment (as % of male employment) of Self-employed in 1985 to that in 1989?
Provide a short and direct response. 0.95. What is the ratio of the Employment (as % of male employment) of Agriculture in 1985 to that in 1990?
Give a very brief answer. 1.07. What is the ratio of the Employment (as % of male employment) of Industry in 1985 to that in 1990?
Your answer should be very brief. 0.79. What is the ratio of the Employment (as % of male employment) in Services in 1985 to that in 1990?
Your answer should be compact. 1.11. What is the ratio of the Employment (as % of male employment) in Self-employed in 1985 to that in 1990?
Your answer should be compact. 0.92. What is the ratio of the Employment (as % of male employment) of Industry in 1986 to that in 1987?
Your answer should be very brief. 0.92. What is the ratio of the Employment (as % of male employment) in Services in 1986 to that in 1987?
Your response must be concise. 1.04. What is the ratio of the Employment (as % of male employment) of Self-employed in 1986 to that in 1987?
Keep it short and to the point. 1.02. What is the ratio of the Employment (as % of male employment) in Agriculture in 1986 to that in 1988?
Offer a very short reply. 1.04. What is the ratio of the Employment (as % of male employment) in Industry in 1986 to that in 1988?
Ensure brevity in your answer.  0.84. What is the ratio of the Employment (as % of male employment) of Services in 1986 to that in 1988?
Provide a succinct answer. 1.08. What is the ratio of the Employment (as % of male employment) of Self-employed in 1986 to that in 1988?
Ensure brevity in your answer.  1.01. What is the ratio of the Employment (as % of male employment) in Agriculture in 1986 to that in 1989?
Your answer should be compact. 1.08. What is the ratio of the Employment (as % of male employment) in Industry in 1986 to that in 1989?
Ensure brevity in your answer.  0.79. What is the ratio of the Employment (as % of male employment) in Services in 1986 to that in 1989?
Offer a terse response. 1.1. What is the ratio of the Employment (as % of male employment) in Self-employed in 1986 to that in 1989?
Your response must be concise. 1. What is the ratio of the Employment (as % of male employment) in Agriculture in 1986 to that in 1990?
Offer a very short reply. 1.08. What is the ratio of the Employment (as % of male employment) in Industry in 1986 to that in 1990?
Offer a very short reply. 0.82. What is the ratio of the Employment (as % of male employment) of Services in 1986 to that in 1990?
Make the answer very short. 1.08. What is the ratio of the Employment (as % of male employment) in Self-employed in 1986 to that in 1990?
Your response must be concise. 0.97. What is the ratio of the Employment (as % of male employment) in Agriculture in 1987 to that in 1988?
Give a very brief answer. 1.04. What is the ratio of the Employment (as % of male employment) in Industry in 1987 to that in 1988?
Offer a terse response. 0.91. What is the ratio of the Employment (as % of male employment) in Services in 1987 to that in 1988?
Your answer should be very brief. 1.04. What is the ratio of the Employment (as % of male employment) of Agriculture in 1987 to that in 1989?
Ensure brevity in your answer.  1.08. What is the ratio of the Employment (as % of male employment) in Industry in 1987 to that in 1989?
Your response must be concise. 0.86. What is the ratio of the Employment (as % of male employment) in Services in 1987 to that in 1989?
Provide a succinct answer. 1.05. What is the ratio of the Employment (as % of male employment) in Self-employed in 1987 to that in 1989?
Your response must be concise. 0.98. What is the ratio of the Employment (as % of male employment) in Agriculture in 1987 to that in 1990?
Give a very brief answer. 1.08. What is the ratio of the Employment (as % of male employment) of Industry in 1987 to that in 1990?
Offer a very short reply. 0.89. What is the ratio of the Employment (as % of male employment) in Services in 1987 to that in 1990?
Give a very brief answer. 1.03. What is the ratio of the Employment (as % of male employment) in Agriculture in 1988 to that in 1989?
Provide a short and direct response. 1.04. What is the ratio of the Employment (as % of male employment) of Industry in 1988 to that in 1989?
Your answer should be compact. 0.95. What is the ratio of the Employment (as % of male employment) in Services in 1988 to that in 1989?
Keep it short and to the point. 1.02. What is the ratio of the Employment (as % of male employment) in Agriculture in 1988 to that in 1990?
Offer a very short reply. 1.04. What is the ratio of the Employment (as % of male employment) in Industry in 1988 to that in 1990?
Your answer should be very brief. 0.97. What is the ratio of the Employment (as % of male employment) of Services in 1988 to that in 1990?
Make the answer very short. 1. What is the ratio of the Employment (as % of male employment) of Agriculture in 1989 to that in 1990?
Keep it short and to the point. 1. What is the ratio of the Employment (as % of male employment) in Industry in 1989 to that in 1990?
Your answer should be compact. 1.03. What is the ratio of the Employment (as % of male employment) in Services in 1989 to that in 1990?
Keep it short and to the point. 0.98. What is the ratio of the Employment (as % of male employment) in Self-employed in 1989 to that in 1990?
Keep it short and to the point. 0.97. What is the difference between the highest and the second highest Employment (as % of male employment) of Industry?
Provide a short and direct response. 0.9. What is the difference between the highest and the second highest Employment (as % of male employment) of Self-employed?
Your answer should be very brief. 1.1. What is the difference between the highest and the lowest Employment (as % of male employment) of Self-employed?
Give a very brief answer. 7.2. 